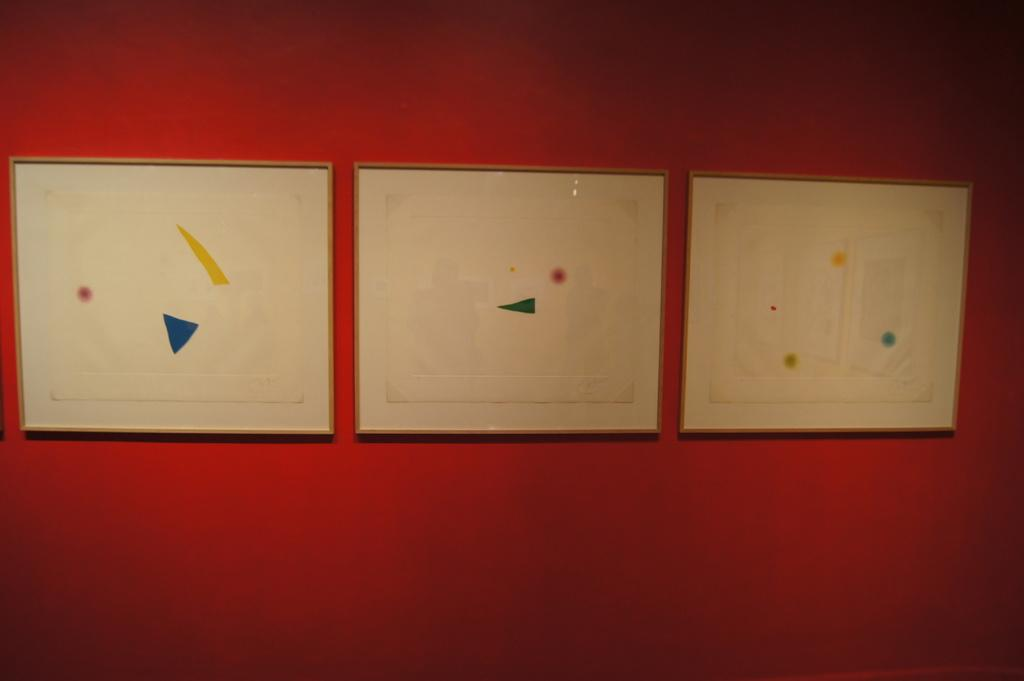What can be seen hanging on the wall in the image? There are frames in the image. What is the color of the wall on which the frames are hung? The wall is red in color. Are there any bells hanging alongside the frames in the image? There is no mention of bells in the image; only frames are present. 